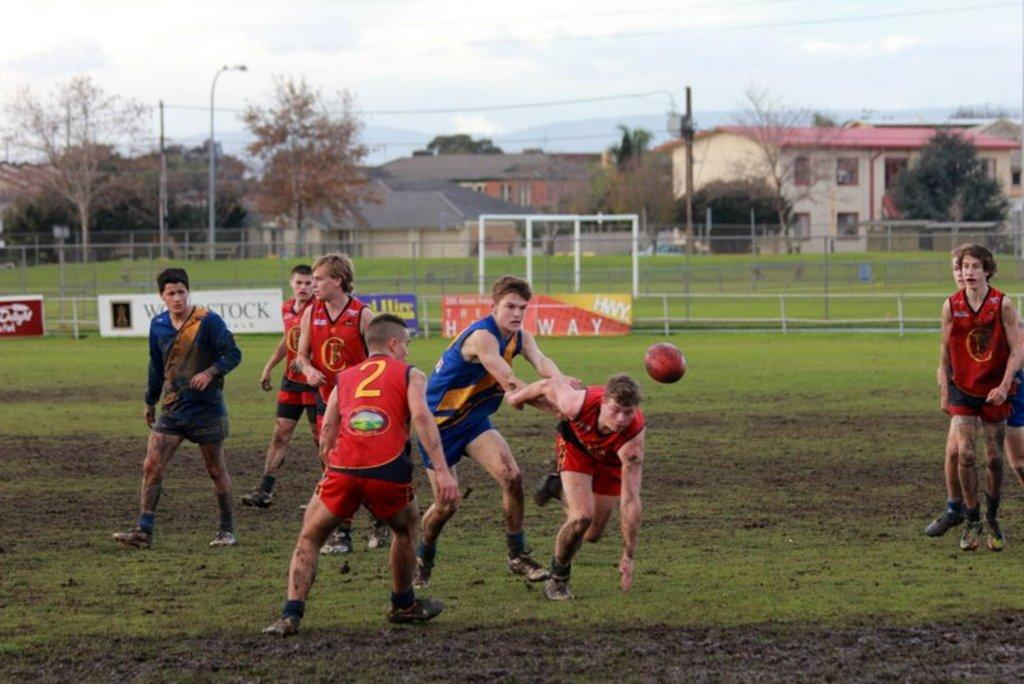<image>
Present a compact description of the photo's key features. the number 2 is on the back of a red jersey 